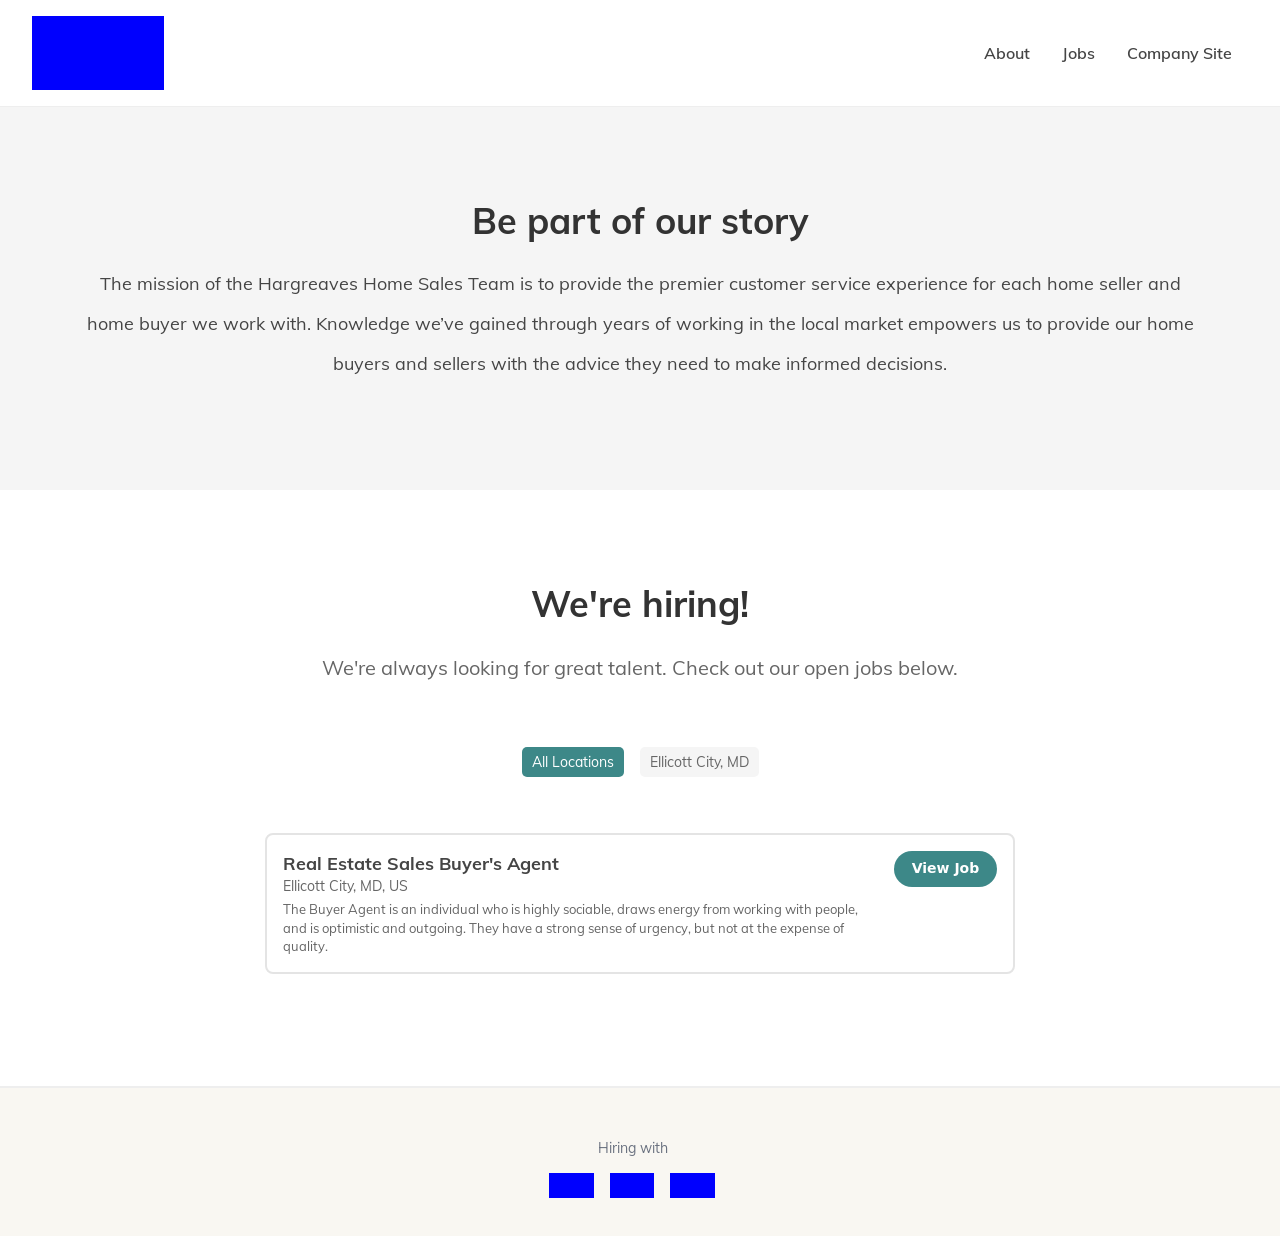What positions are currently available at the Hargreaves Home Sales Team? Currently, there is an opening for a Real Estate Sales Buyer’s Agent in Ellicott City, MD. This role seeks a sociable and optimistic individual who thrives in a dynamic environment. 